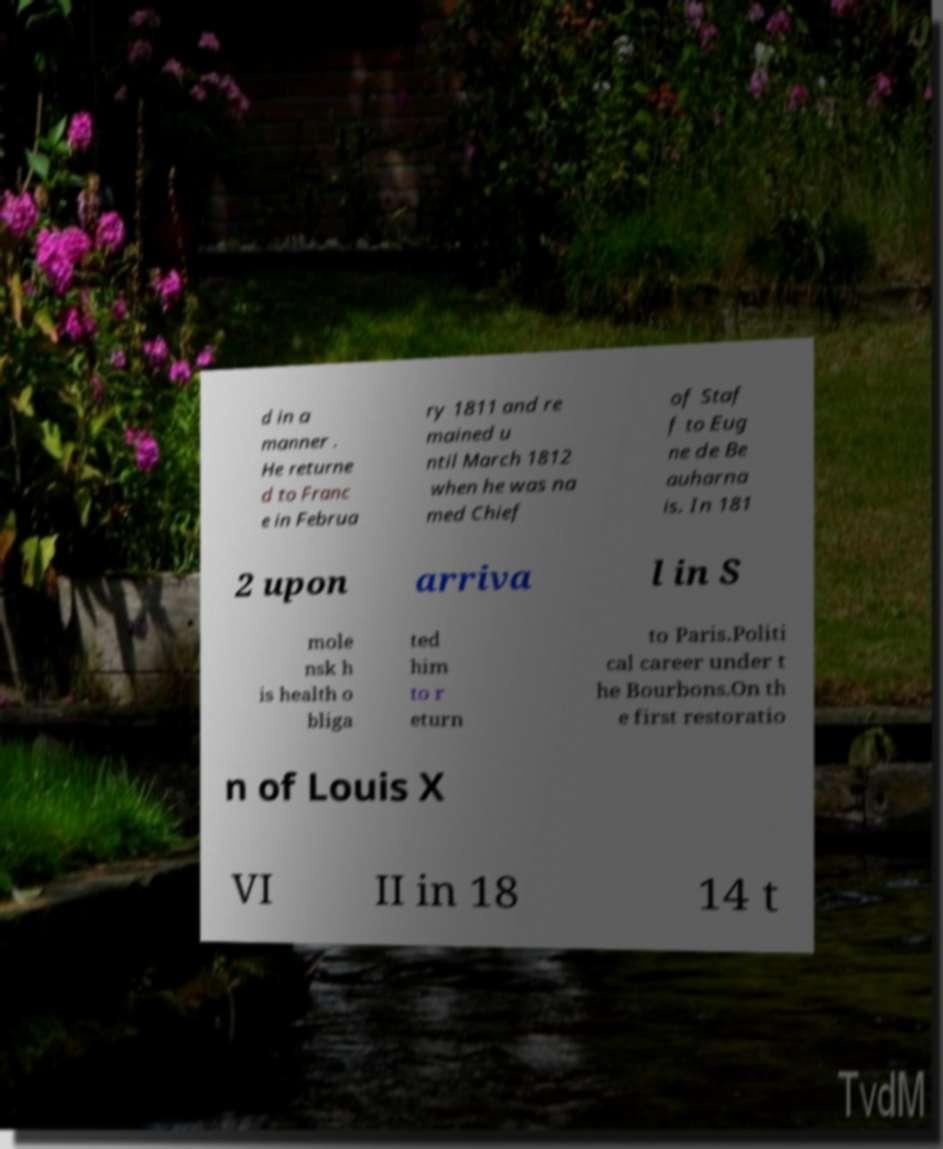Please identify and transcribe the text found in this image. d in a manner . He returne d to Franc e in Februa ry 1811 and re mained u ntil March 1812 when he was na med Chief of Staf f to Eug ne de Be auharna is. In 181 2 upon arriva l in S mole nsk h is health o bliga ted him to r eturn to Paris.Politi cal career under t he Bourbons.On th e first restoratio n of Louis X VI II in 18 14 t 